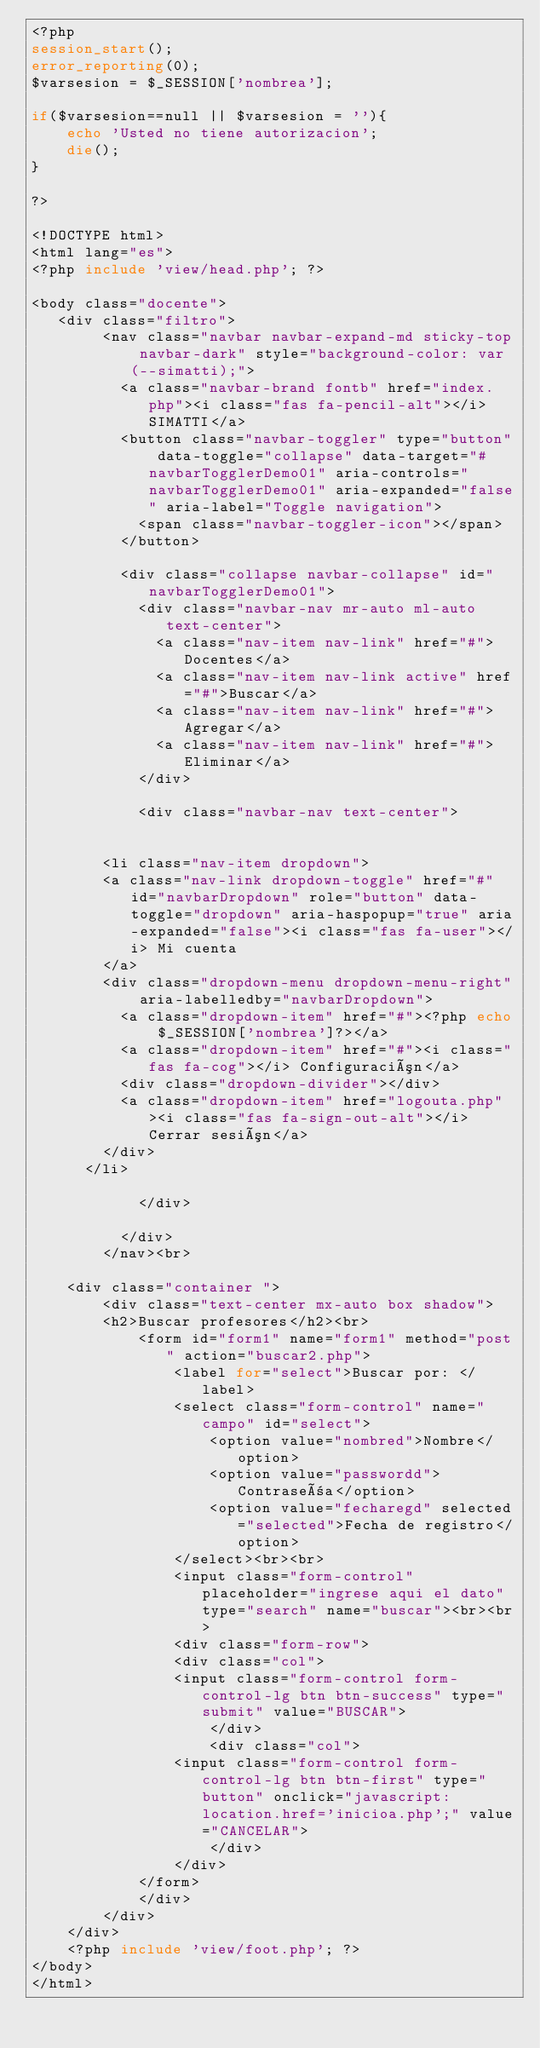<code> <loc_0><loc_0><loc_500><loc_500><_PHP_><?php
session_start();
error_reporting(0);
$varsesion = $_SESSION['nombrea'];

if($varsesion==null || $varsesion = ''){
	echo 'Usted no tiene autorizacion';
	die(); 
}

?>

<!DOCTYPE html>
<html lang="es">
<?php include 'view/head.php'; ?>

<body class="docente">
   <div class="filtro">
		<nav class="navbar navbar-expand-md sticky-top navbar-dark" style="background-color: var(--simatti);">
		  <a class="navbar-brand fontb" href="index.php"><i class="fas fa-pencil-alt"></i> SIMATTI</a>
		  <button class="navbar-toggler" type="button" data-toggle="collapse" data-target="#navbarTogglerDemo01" aria-controls="navbarTogglerDemo01" aria-expanded="false" aria-label="Toggle navigation">
		  	<span class="navbar-toggler-icon"></span>
		  </button>

		  <div class="collapse navbar-collapse" id="navbarTogglerDemo01">
		    <div class="navbar-nav mr-auto ml-auto text-center">
		      <a class="nav-item nav-link" href="#">Docentes</a>
		      <a class="nav-item nav-link active" href="#">Buscar</a>
		      <a class="nav-item nav-link" href="#">Agregar</a>
		      <a class="nav-item nav-link" href="#">Eliminar</a>
		    </div>

		    <div class="navbar-nav text-center">
			
		
		<li class="nav-item dropdown">	
        <a class="nav-link dropdown-toggle" href="#" id="navbarDropdown" role="button" data-toggle="dropdown" aria-haspopup="true" aria-expanded="false"><i class="fas fa-user"></i> Mi cuenta
        </a>
        <div class="dropdown-menu dropdown-menu-right" aria-labelledby="navbarDropdown">
          <a class="dropdown-item" href="#"><?php echo $_SESSION['nombrea']?></a>
          <a class="dropdown-item" href="#"><i class="fas fa-cog"></i> Configuración</a>
          <div class="dropdown-divider"></div>
          <a class="dropdown-item" href="logouta.php"><i class="fas fa-sign-out-alt"></i> Cerrar sesión</a>
        </div>
      </li>

		    </div>

		  </div>
		</nav><br>

	<div class="container ">
		<div class="text-center mx-auto box shadow">
		<h2>Buscar profesores</h2><br>
            <form id="form1" name="form1" method="post" action="buscar2.php">
                <label for="select">Buscar por: </label>
                <select class="form-control" name="campo" id="select">
                    <option value="nombred">Nombre</option>
                    <option value="passwordd">Contraseña</option>
                    <option value="fecharegd" selected="selected">Fecha de registro</option>
                </select><br><br>
                <input class="form-control" placeholder="ingrese aqui el dato" type="search" name="buscar"><br><br>
                <div class="form-row">
                <div class="col">
                <input class="form-control form-control-lg btn btn-success" type="submit" value="BUSCAR">
                    </div>
                    <div class="col">
                <input class="form-control form-control-lg btn btn-first" type="button" onclick="javascript:location.href='inicioa.php';" value="CANCELAR">
                    </div>
                </div>
            </form>
            </div>
		</div>
	</div>
	<?php include 'view/foot.php'; ?>
</body>
</html></code> 